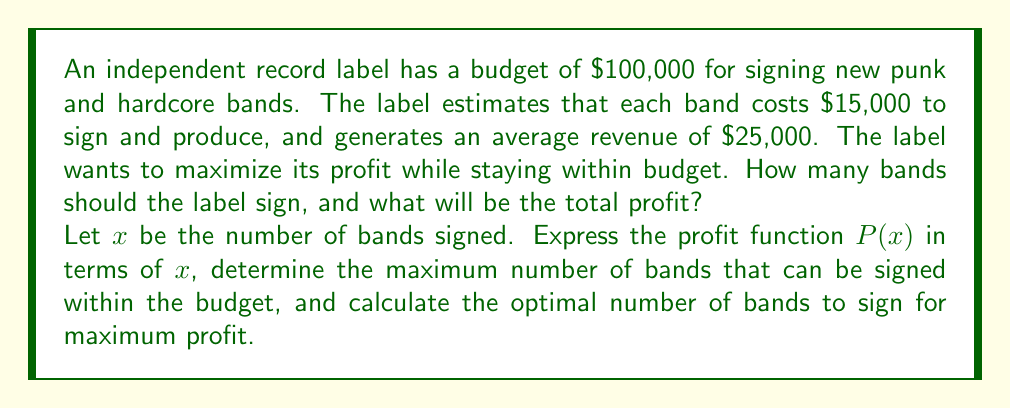Give your solution to this math problem. 1. Express the profit function:
   Revenue per band: $25,000
   Cost per band: $15,000
   Profit per band: $25,000 - $15,000 = $10,000
   
   Profit function: $P(x) = 10000x$

2. Determine the maximum number of bands that can be signed:
   Budget constraint: $15000x \leq 100000$
   Solving for $x$: $x \leq \frac{100000}{15000} = \frac{20}{3} \approx 6.67$
   
   Since we can't sign a fraction of a band, the maximum is 6 bands.

3. Calculate profit for each possible number of bands:
   For 1 band: $P(1) = 10000(1) = 10000$
   For 2 bands: $P(2) = 10000(2) = 20000$
   For 3 bands: $P(3) = 10000(3) = 30000$
   For 4 bands: $P(4) = 10000(4) = 40000$
   For 5 bands: $P(5) = 10000(5) = 50000$
   For 6 bands: $P(6) = 10000(6) = 60000$

4. The profit increases linearly with the number of bands, so the maximum profit is achieved by signing the maximum number of bands possible within the budget constraint.

Therefore, the optimal number of bands to sign is 6, which will result in a total profit of $60,000.
Answer: 6 bands; $60,000 profit 